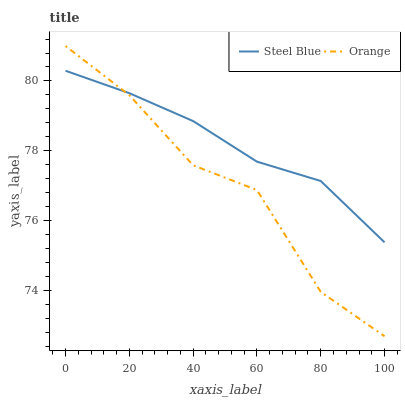Does Orange have the minimum area under the curve?
Answer yes or no. Yes. Does Steel Blue have the maximum area under the curve?
Answer yes or no. Yes. Does Steel Blue have the minimum area under the curve?
Answer yes or no. No. Is Steel Blue the smoothest?
Answer yes or no. Yes. Is Orange the roughest?
Answer yes or no. Yes. Is Steel Blue the roughest?
Answer yes or no. No. Does Orange have the lowest value?
Answer yes or no. Yes. Does Steel Blue have the lowest value?
Answer yes or no. No. Does Orange have the highest value?
Answer yes or no. Yes. Does Steel Blue have the highest value?
Answer yes or no. No. Does Steel Blue intersect Orange?
Answer yes or no. Yes. Is Steel Blue less than Orange?
Answer yes or no. No. Is Steel Blue greater than Orange?
Answer yes or no. No. 